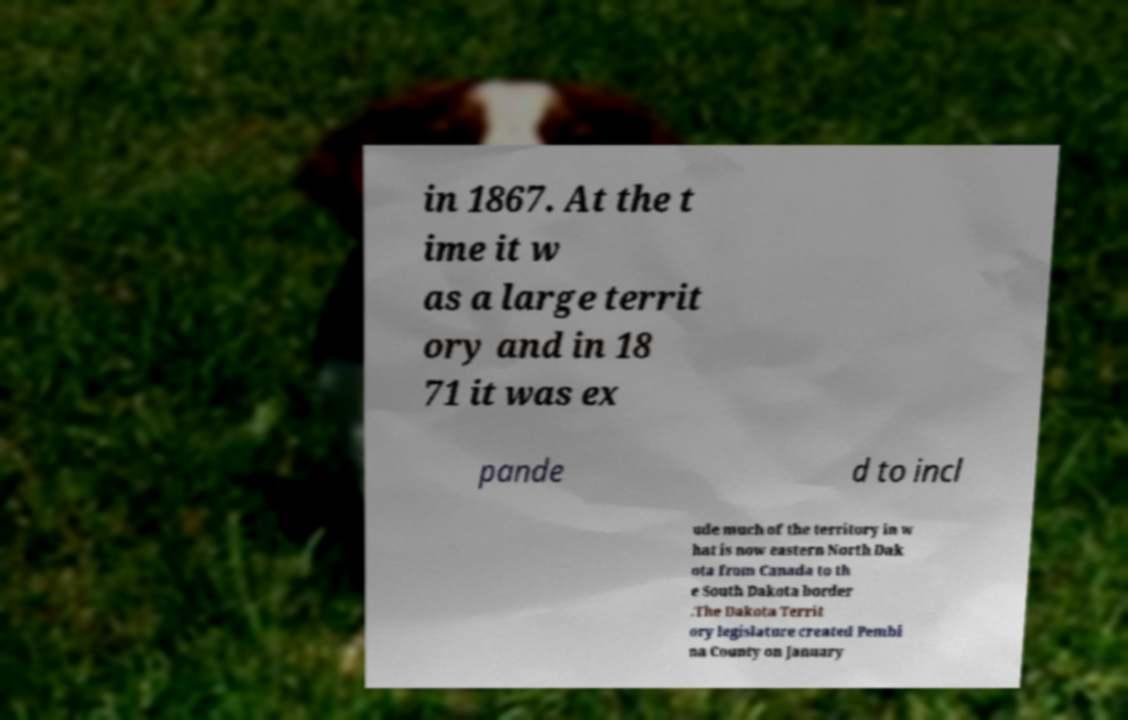For documentation purposes, I need the text within this image transcribed. Could you provide that? in 1867. At the t ime it w as a large territ ory and in 18 71 it was ex pande d to incl ude much of the territory in w hat is now eastern North Dak ota from Canada to th e South Dakota border .The Dakota Territ ory legislature created Pembi na County on January 